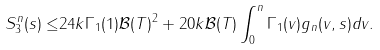Convert formula to latex. <formula><loc_0><loc_0><loc_500><loc_500>S _ { 3 } ^ { n } ( s ) \leq & 2 4 k \Gamma _ { 1 } ( 1 ) \mathcal { B } ( T ) ^ { 2 } + 2 0 k \mathcal { B } ( T ) \int _ { 0 } ^ { n } \Gamma _ { 1 } ( v ) g _ { n } ( v , s ) d v .</formula> 